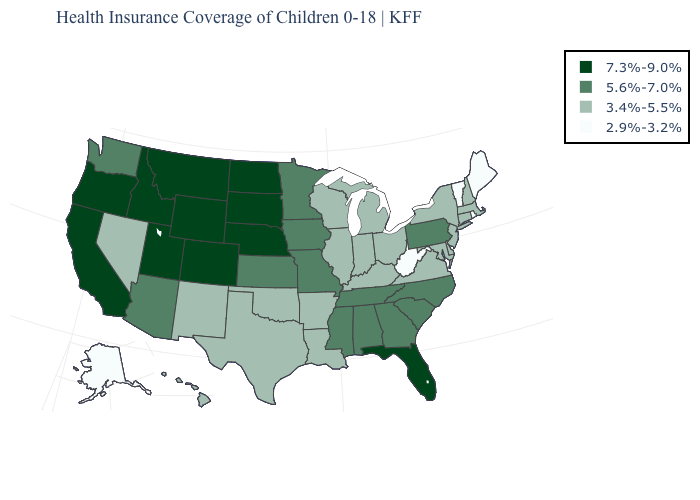Does the first symbol in the legend represent the smallest category?
Write a very short answer. No. How many symbols are there in the legend?
Quick response, please. 4. What is the value of Nevada?
Answer briefly. 3.4%-5.5%. Name the states that have a value in the range 3.4%-5.5%?
Keep it brief. Arkansas, Connecticut, Delaware, Hawaii, Illinois, Indiana, Kentucky, Louisiana, Maryland, Massachusetts, Michigan, Nevada, New Hampshire, New Jersey, New Mexico, New York, Ohio, Oklahoma, Texas, Virginia, Wisconsin. What is the value of Maine?
Short answer required. 2.9%-3.2%. Does Nebraska have the lowest value in the USA?
Concise answer only. No. Does Alaska have the lowest value in the USA?
Concise answer only. Yes. Which states hav the highest value in the South?
Short answer required. Florida. What is the value of Connecticut?
Keep it brief. 3.4%-5.5%. Which states have the highest value in the USA?
Write a very short answer. California, Colorado, Florida, Idaho, Montana, Nebraska, North Dakota, Oregon, South Dakota, Utah, Wyoming. Name the states that have a value in the range 5.6%-7.0%?
Give a very brief answer. Alabama, Arizona, Georgia, Iowa, Kansas, Minnesota, Mississippi, Missouri, North Carolina, Pennsylvania, South Carolina, Tennessee, Washington. What is the value of Maine?
Keep it brief. 2.9%-3.2%. Does the map have missing data?
Keep it brief. No. 